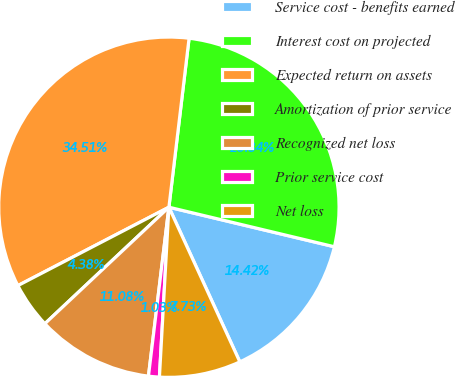Convert chart. <chart><loc_0><loc_0><loc_500><loc_500><pie_chart><fcel>Service cost - benefits earned<fcel>Interest cost on projected<fcel>Expected return on assets<fcel>Amortization of prior service<fcel>Recognized net loss<fcel>Prior service cost<fcel>Net loss<nl><fcel>14.42%<fcel>26.84%<fcel>34.51%<fcel>4.38%<fcel>11.08%<fcel>1.03%<fcel>7.73%<nl></chart> 